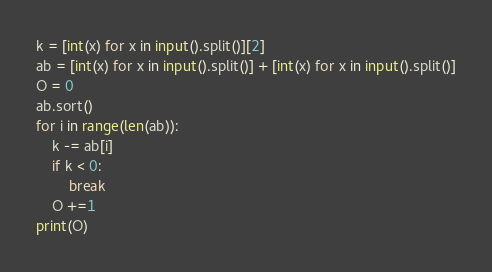Convert code to text. <code><loc_0><loc_0><loc_500><loc_500><_Python_>k = [int(x) for x in input().split()][2]
ab = [int(x) for x in input().split()] + [int(x) for x in input().split()]
O = 0
ab.sort()
for i in range(len(ab)):
    k -= ab[i]
    if k < 0:
        break
    O +=1
print(O)
</code> 